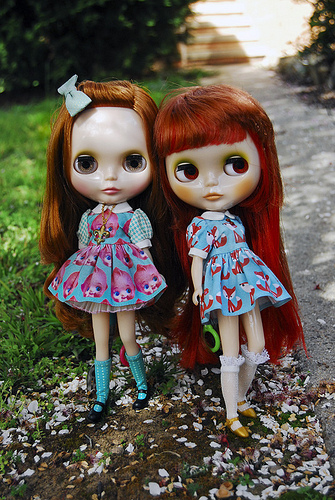<image>
Is there a doll on the dirt? Yes. Looking at the image, I can see the doll is positioned on top of the dirt, with the dirt providing support. 